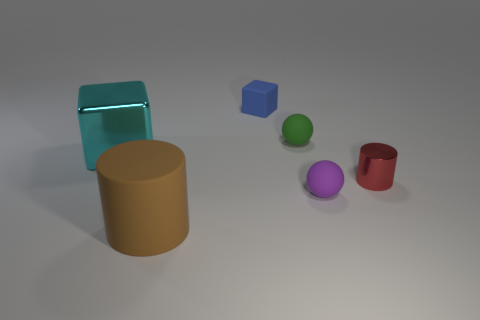There is a sphere behind the small purple sphere; does it have the same size as the sphere in front of the tiny red cylinder?
Your answer should be compact. Yes. Are there any other metal things that have the same shape as the small purple thing?
Keep it short and to the point. No. Is the number of tiny purple rubber balls behind the green matte object the same as the number of cyan matte objects?
Your answer should be compact. Yes. There is a blue rubber object; is it the same size as the matte ball behind the tiny metal cylinder?
Your answer should be very brief. Yes. What number of red things are the same material as the cyan cube?
Make the answer very short. 1. Do the purple thing and the shiny cylinder have the same size?
Your answer should be very brief. Yes. Is there anything else of the same color as the large cube?
Offer a terse response. No. There is a tiny object that is both behind the red shiny object and in front of the matte cube; what shape is it?
Give a very brief answer. Sphere. There is a metal thing on the right side of the blue rubber object; what size is it?
Your answer should be very brief. Small. How many balls are in front of the big metallic thing in front of the cube to the right of the big metal block?
Provide a short and direct response. 1. 